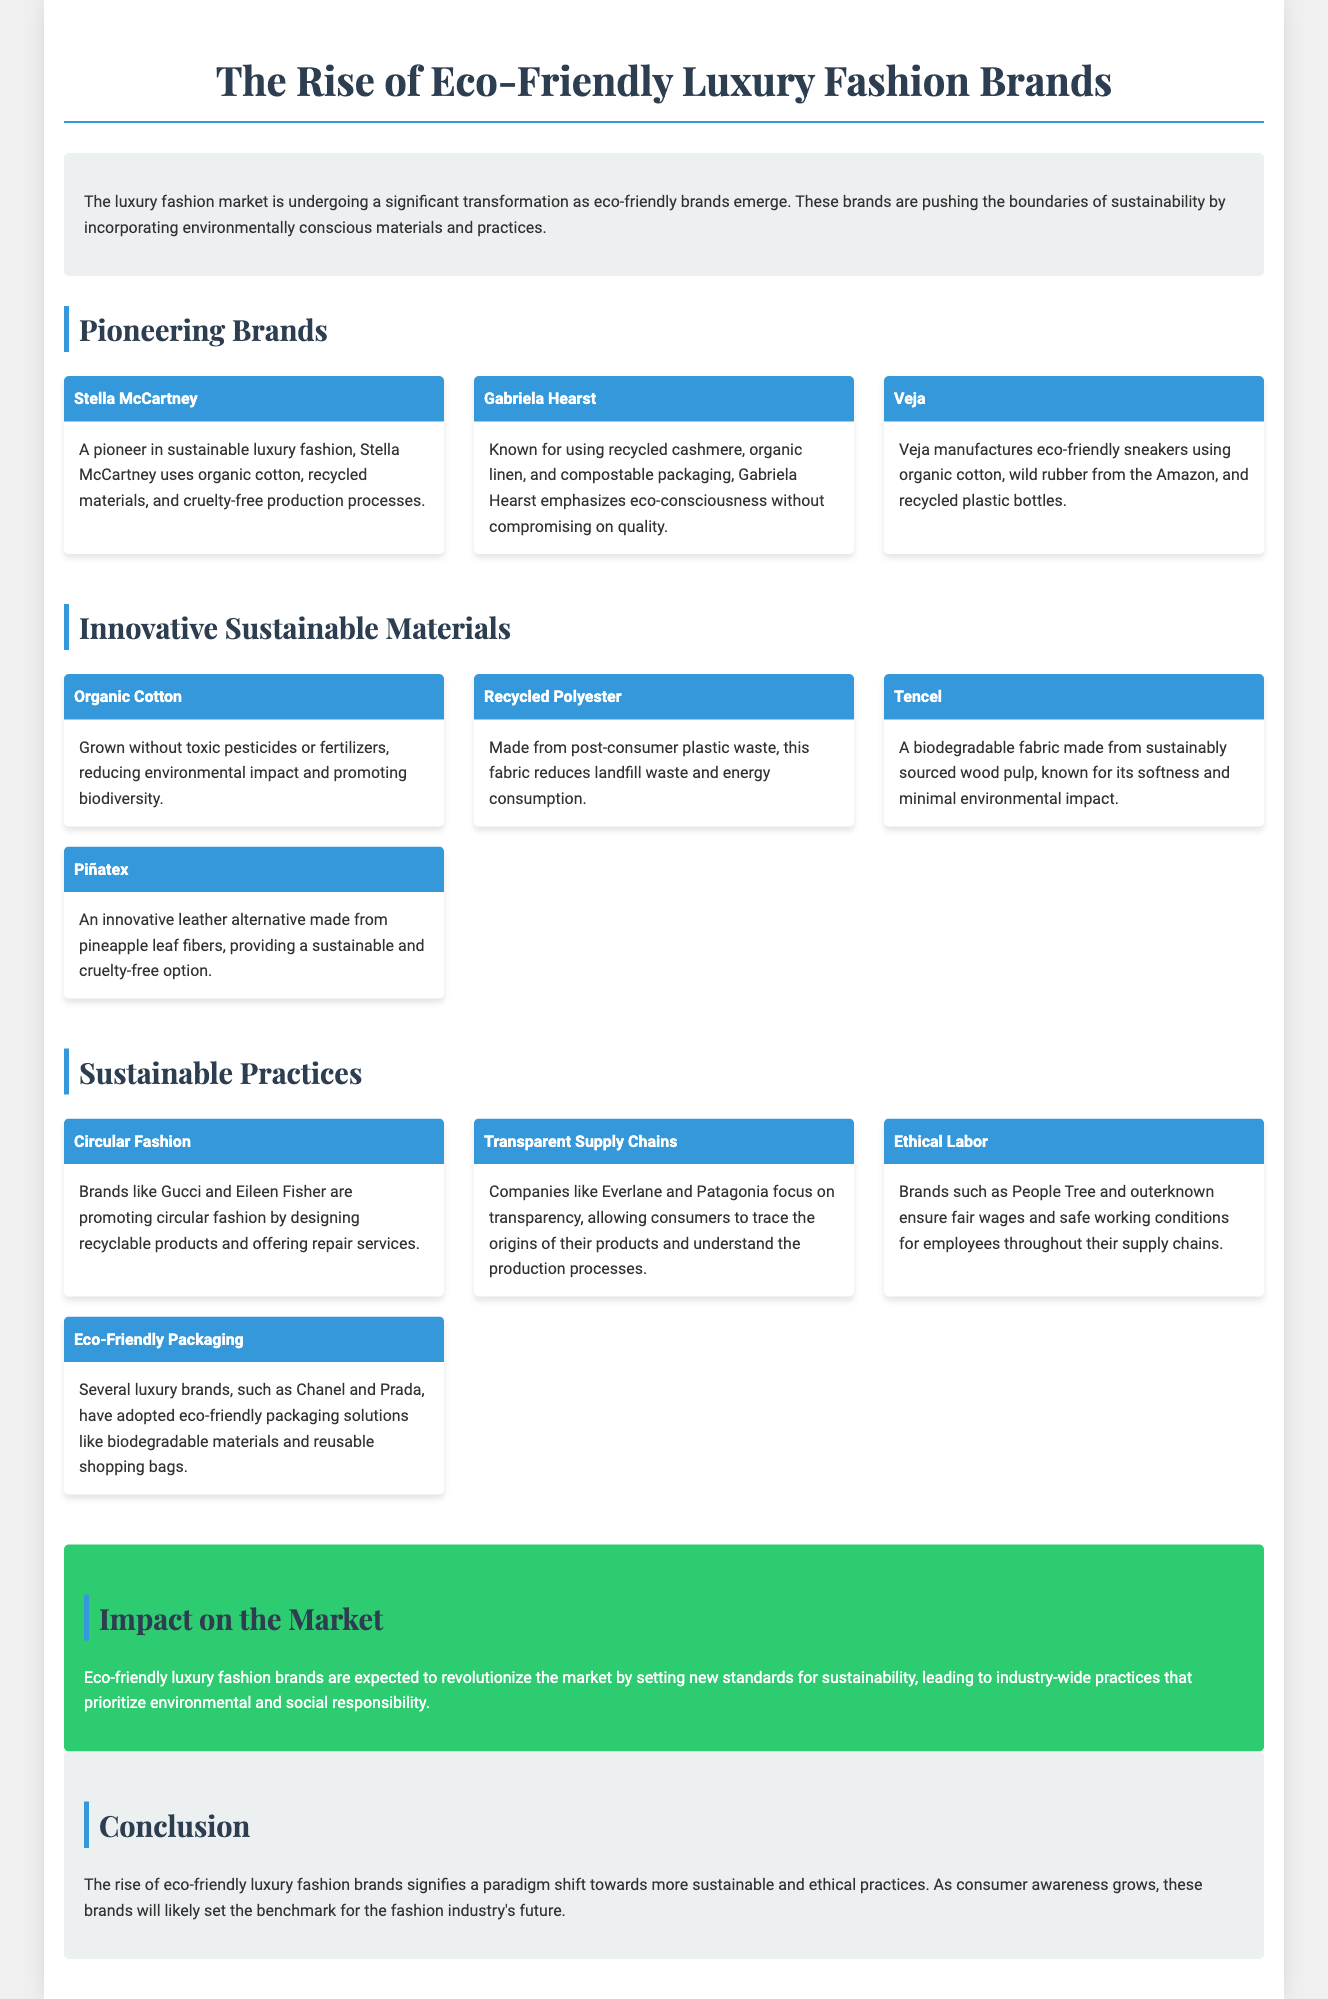What are the names of the pioneering brands mentioned? The document lists three pioneering eco-friendly luxury fashion brands: Stella McCartney, Gabriela Hearst, and Veja.
Answer: Stella McCartney, Gabriela Hearst, Veja What material is made from pineapple leaf fibers? The document mentions that Piñatex is an innovative leather alternative made from pineapple leaf fibers.
Answer: Piñatex Which fabric is created from post-consumer plastic waste? The document describes recycled polyester as a fabric made from post-consumer plastic waste.
Answer: Recycled Polyester What is the focus of companies like Everlane and Patagonia? The document states that these companies focus on transparent supply chains, allowing consumers to trace the origins of their products.
Answer: Transparent Supply Chains How do eco-friendly luxury fashion brands impact the market? The document states that eco-friendly luxury fashion brands are expected to revolutionize the market by setting new standards for sustainability.
Answer: New standards for sustainability Which brand emphasizes eco-consciousness with recycled cashmere and organic linen? The document specifies that Gabriela Hearst is known for using recycled cashmere and organic linen.
Answer: Gabriela Hearst What type of labor practices do brands like People Tree and outerknown ensure? According to the document, these brands ensure ethical labor practices, focusing on fair wages and safe working conditions.
Answer: Ethical Labor What is Tencel made from? The document explains that Tencel is made from sustainably sourced wood pulp.
Answer: Sustainably sourced wood pulp What major trend do circular fashion practices represent? The document highlights that circular fashion is promoted by brands designing recyclable products and offering repair services.
Answer: Circular Fashion 